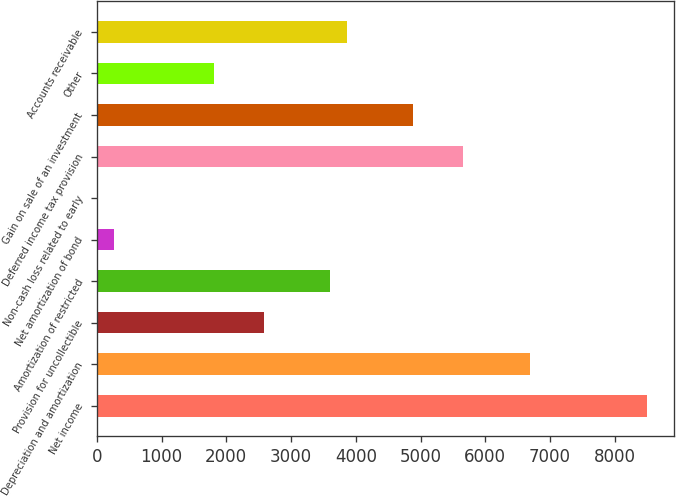Convert chart to OTSL. <chart><loc_0><loc_0><loc_500><loc_500><bar_chart><fcel>Net income<fcel>Depreciation and amortization<fcel>Provision for uncollectible<fcel>Amortization of restricted<fcel>Net amortization of bond<fcel>Non-cash loss related to early<fcel>Deferred income tax provision<fcel>Gain on sale of an investment<fcel>Other<fcel>Accounts receivable<nl><fcel>8493.63<fcel>6692.25<fcel>2574.81<fcel>3604.17<fcel>258.75<fcel>1.41<fcel>5662.89<fcel>4890.87<fcel>1802.79<fcel>3861.51<nl></chart> 